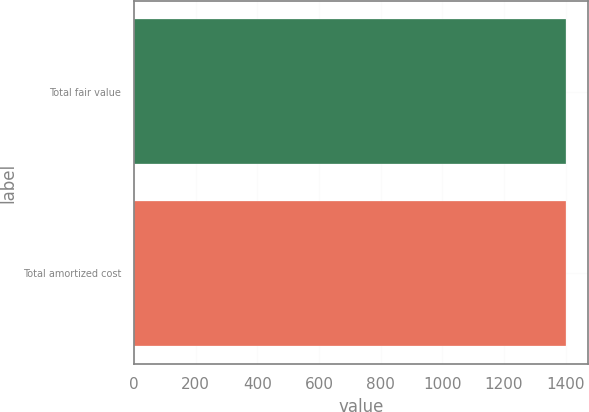Convert chart to OTSL. <chart><loc_0><loc_0><loc_500><loc_500><bar_chart><fcel>Total fair value<fcel>Total amortized cost<nl><fcel>1402<fcel>1401<nl></chart> 